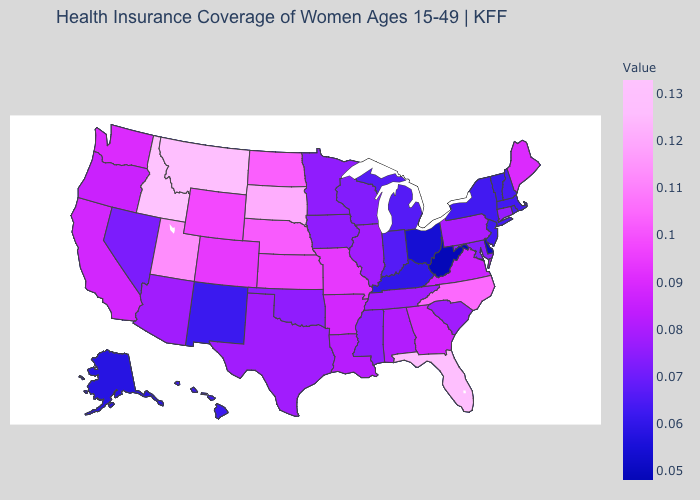Among the states that border Georgia , does North Carolina have the highest value?
Be succinct. No. Is the legend a continuous bar?
Give a very brief answer. Yes. Is the legend a continuous bar?
Concise answer only. Yes. Among the states that border California , does Arizona have the highest value?
Write a very short answer. No. Which states have the lowest value in the USA?
Write a very short answer. West Virginia. Among the states that border South Carolina , which have the highest value?
Quick response, please. North Carolina. 